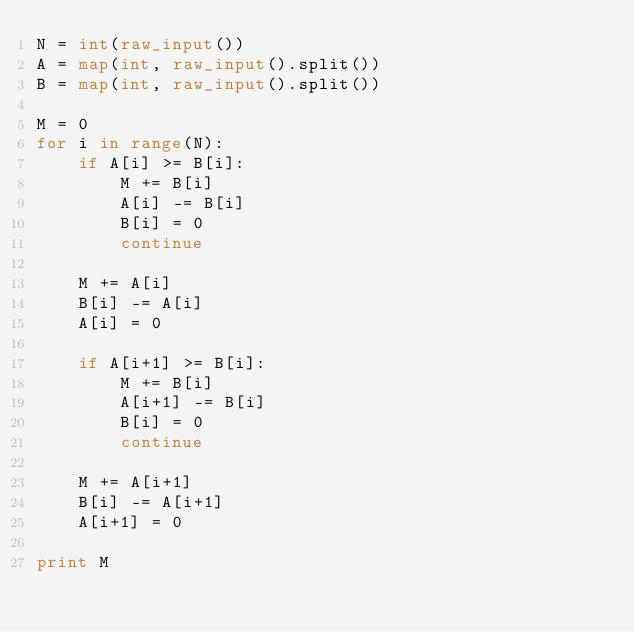Convert code to text. <code><loc_0><loc_0><loc_500><loc_500><_Python_>N = int(raw_input())
A = map(int, raw_input().split())
B = map(int, raw_input().split())

M = 0
for i in range(N):
    if A[i] >= B[i]:
        M += B[i]
        A[i] -= B[i]
        B[i] = 0
        continue

    M += A[i]
    B[i] -= A[i]
    A[i] = 0

    if A[i+1] >= B[i]:
        M += B[i]
        A[i+1] -= B[i]
        B[i] = 0
        continue

    M += A[i+1]
    B[i] -= A[i+1]
    A[i+1] = 0

print M</code> 